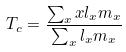<formula> <loc_0><loc_0><loc_500><loc_500>T _ { c } = \frac { \sum _ { x } x l _ { x } m _ { x } } { \sum _ { x } l _ { x } m _ { x } }</formula> 